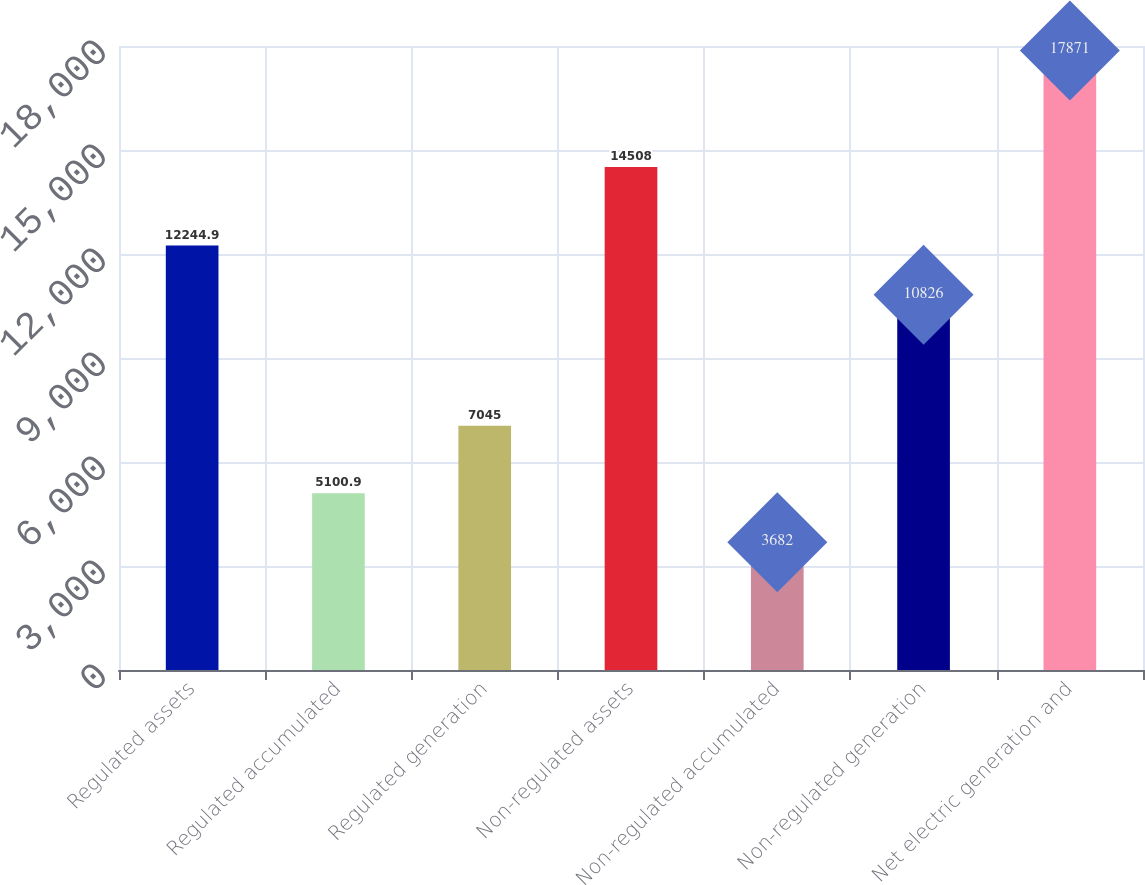<chart> <loc_0><loc_0><loc_500><loc_500><bar_chart><fcel>Regulated assets<fcel>Regulated accumulated<fcel>Regulated generation<fcel>Non-regulated assets<fcel>Non-regulated accumulated<fcel>Non-regulated generation<fcel>Net electric generation and<nl><fcel>12244.9<fcel>5100.9<fcel>7045<fcel>14508<fcel>3682<fcel>10826<fcel>17871<nl></chart> 